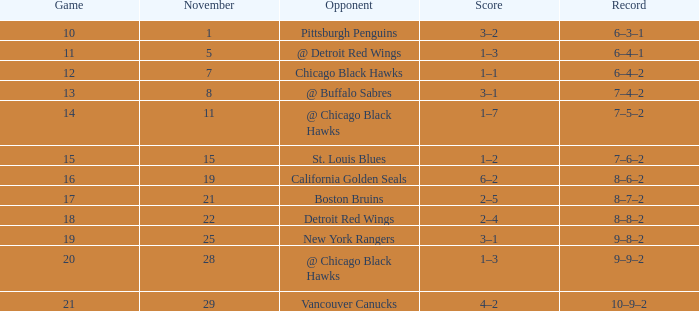Could you help me parse every detail presented in this table? {'header': ['Game', 'November', 'Opponent', 'Score', 'Record'], 'rows': [['10', '1', 'Pittsburgh Penguins', '3–2', '6–3–1'], ['11', '5', '@ Detroit Red Wings', '1–3', '6–4–1'], ['12', '7', 'Chicago Black Hawks', '1–1', '6–4–2'], ['13', '8', '@ Buffalo Sabres', '3–1', '7–4–2'], ['14', '11', '@ Chicago Black Hawks', '1–7', '7–5–2'], ['15', '15', 'St. Louis Blues', '1–2', '7–6–2'], ['16', '19', 'California Golden Seals', '6–2', '8–6–2'], ['17', '21', 'Boston Bruins', '2–5', '8–7–2'], ['18', '22', 'Detroit Red Wings', '2–4', '8–8–2'], ['19', '25', 'New York Rangers', '3–1', '9–8–2'], ['20', '28', '@ Chicago Black Hawks', '1–3', '9–9–2'], ['21', '29', 'Vancouver Canucks', '4–2', '10–9–2']]} What record has a november greater than 11, and st. louis blues as the opponent? 7–6–2. 